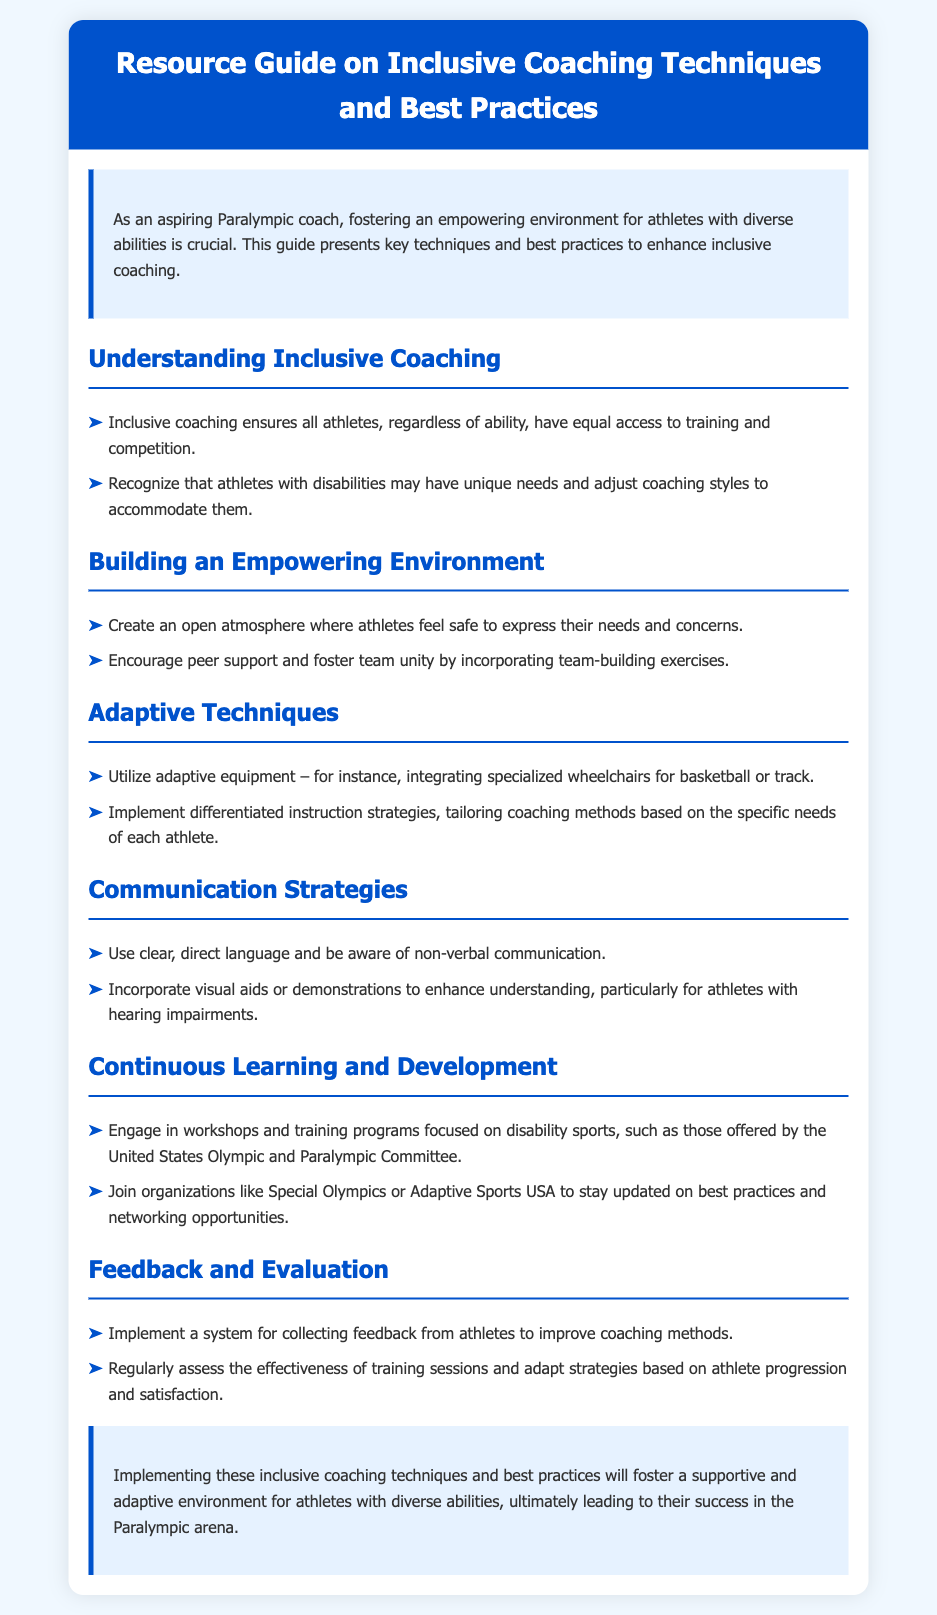what is the title of the document? The title is presented at the top of the document, clearly indicating the subject matter.
Answer: Resource Guide on Inclusive Coaching Techniques and Best Practices what is the purpose of the guide? The purpose is outlined in the introduction, highlighting the importance of creating a supportive environment for athletes.
Answer: Fostering an empowering environment for athletes with diverse abilities how many sections does the document have? The sections of the content provide structured information; counting them gives the total.
Answer: Five name one adaptive technique mentioned in the document. The document lists specific adaptive techniques under the respective section on adaptive techniques.
Answer: Utilizing adaptive equipment what type of organizations should coaches join for updates? The document suggests organizations that support networking and best practices for adaptive sports.
Answer: Special Olympics or Adaptive Sports USA which section focuses on communication? One of the sections specifically addresses methods and strategies for communication in coaching.
Answer: Communication Strategies how should coaches gather feedback from athletes? The document specifies a method for collecting feedback aimed at improving coaching methods.
Answer: Implement a system for collecting feedback what is a key element in building an empowering environment? The document emphasizes elements crucial to creating a supportive team environment for athletes.
Answer: Creating an open atmosphere 